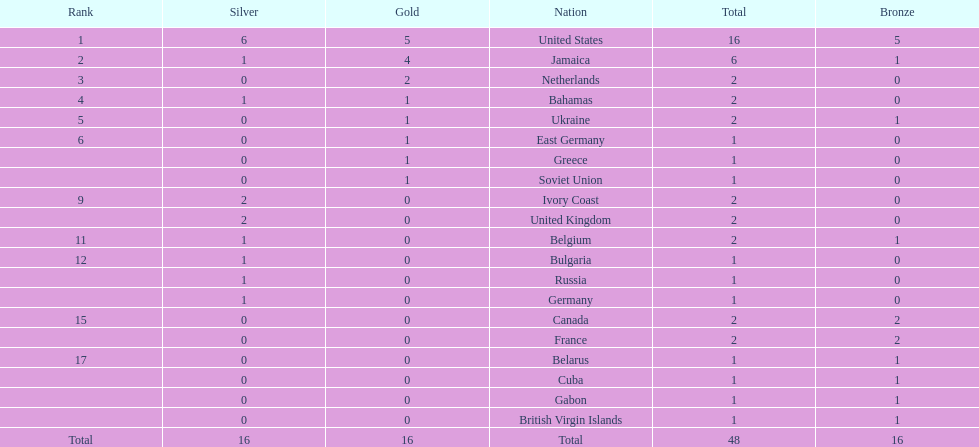Which countries won at least 3 silver medals? United States. 